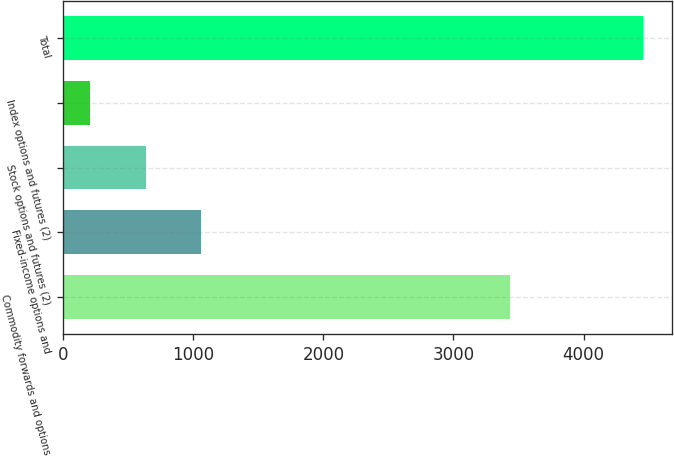Convert chart. <chart><loc_0><loc_0><loc_500><loc_500><bar_chart><fcel>Commodity forwards and options<fcel>Fixed-income options and<fcel>Stock options and futures (2)<fcel>Index options and futures (2)<fcel>Total<nl><fcel>3437<fcel>1058.4<fcel>633.2<fcel>208<fcel>4460<nl></chart> 